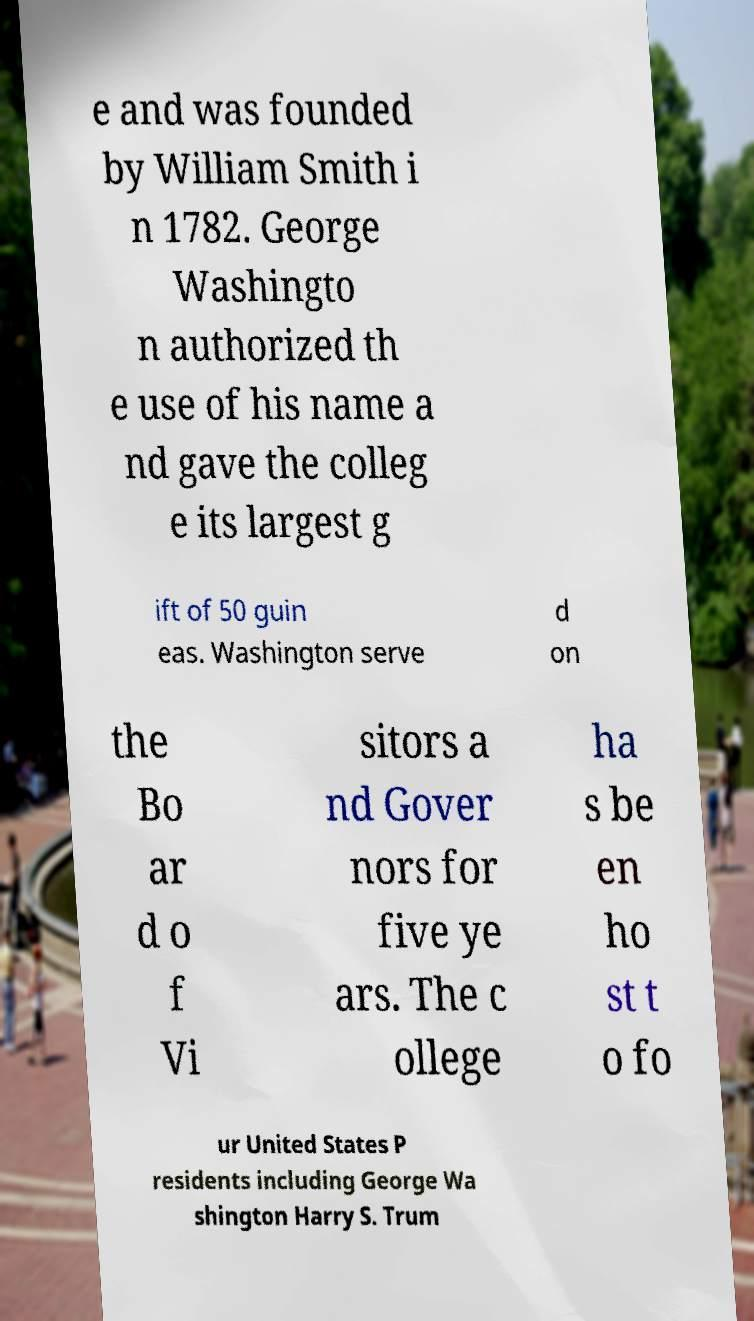Please read and relay the text visible in this image. What does it say? e and was founded by William Smith i n 1782. George Washingto n authorized th e use of his name a nd gave the colleg e its largest g ift of 50 guin eas. Washington serve d on the Bo ar d o f Vi sitors a nd Gover nors for five ye ars. The c ollege ha s be en ho st t o fo ur United States P residents including George Wa shington Harry S. Trum 